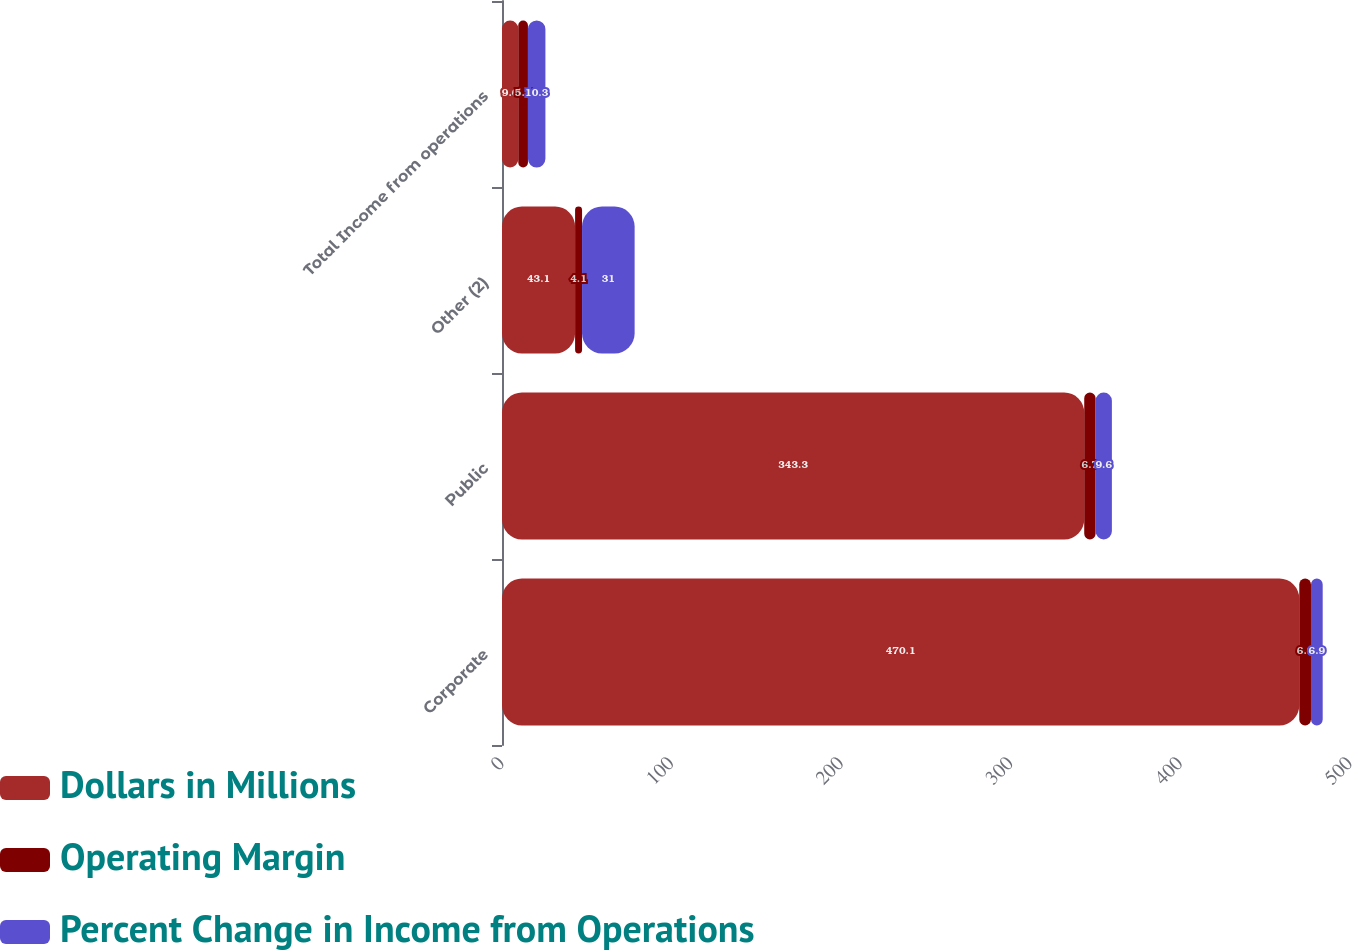Convert chart. <chart><loc_0><loc_0><loc_500><loc_500><stacked_bar_chart><ecel><fcel>Corporate<fcel>Public<fcel>Other (2)<fcel>Total Income from operations<nl><fcel>Dollars in Millions<fcel>470.1<fcel>343.3<fcel>43.1<fcel>9.6<nl><fcel>Operating Margin<fcel>6.9<fcel>6.7<fcel>4.1<fcel>5.7<nl><fcel>Percent Change in Income from Operations<fcel>6.9<fcel>9.6<fcel>31<fcel>10.3<nl></chart> 